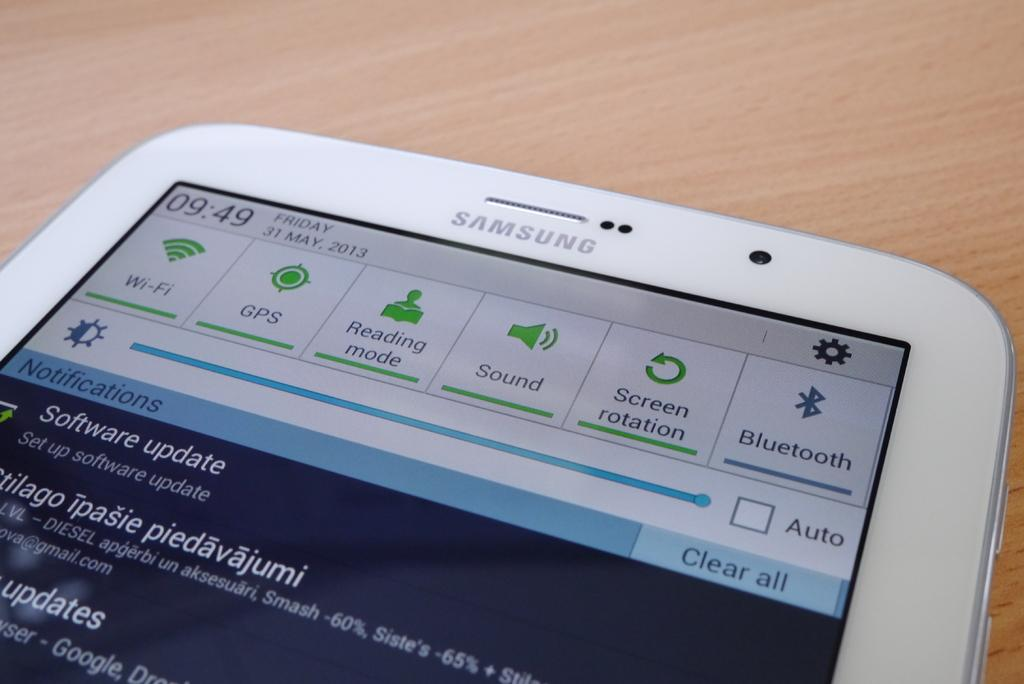<image>
Create a compact narrative representing the image presented. A Samsung phone is displaying a software update. 